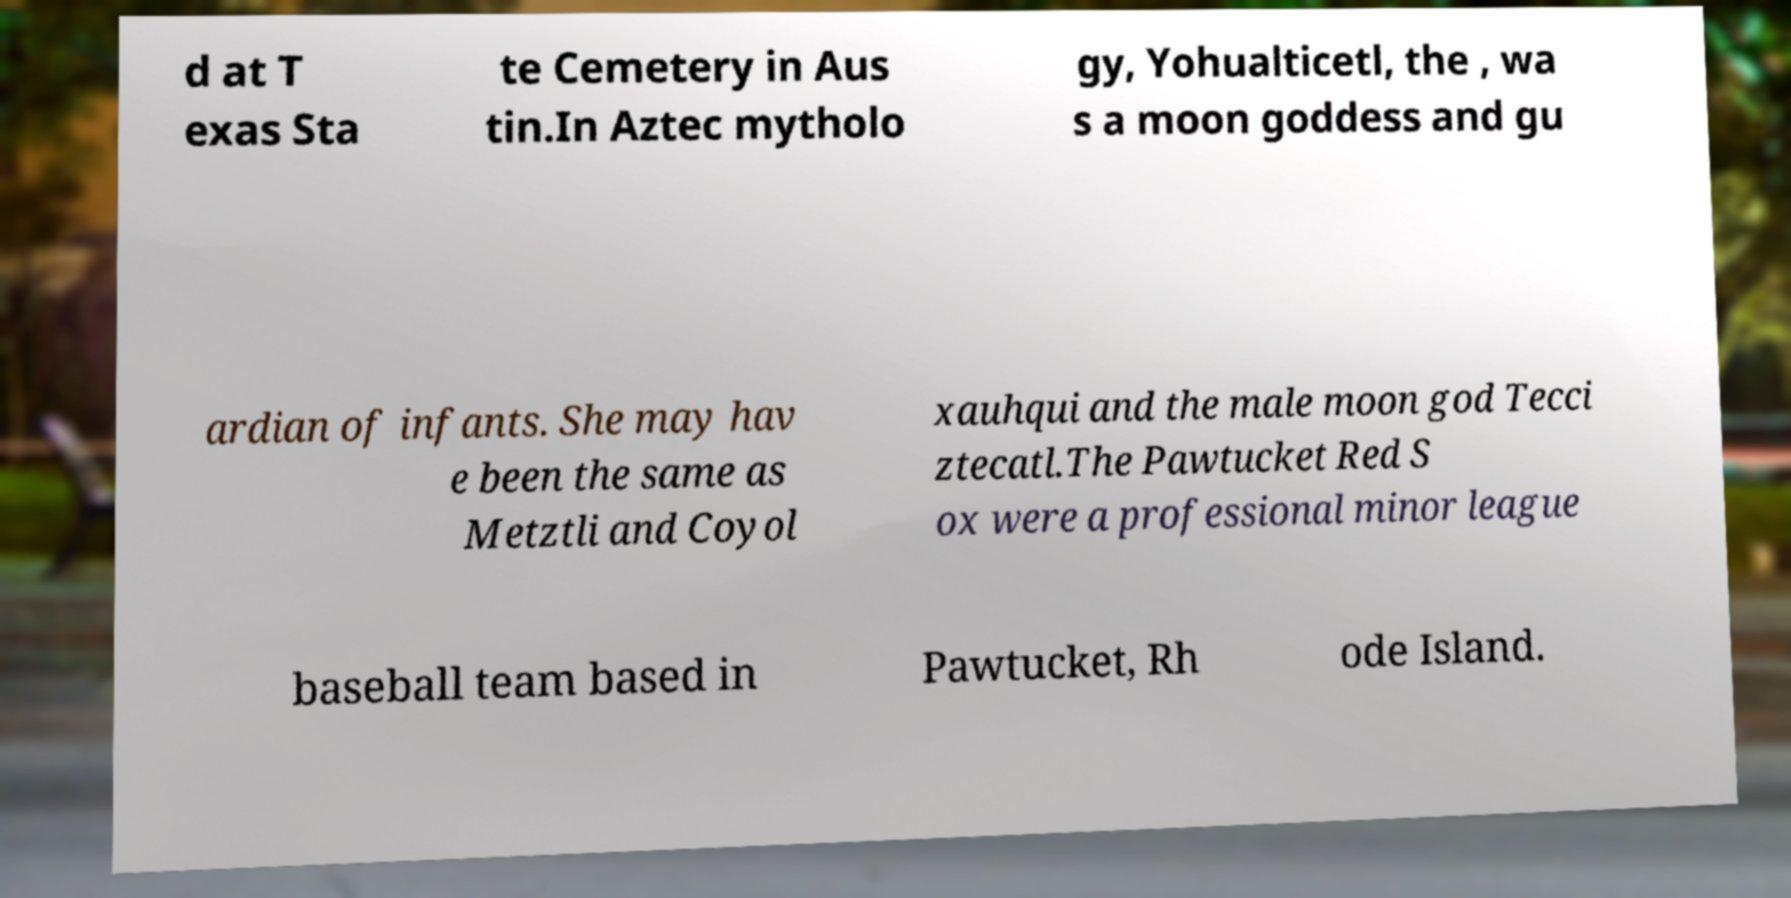Can you read and provide the text displayed in the image?This photo seems to have some interesting text. Can you extract and type it out for me? d at T exas Sta te Cemetery in Aus tin.In Aztec mytholo gy, Yohualticetl, the , wa s a moon goddess and gu ardian of infants. She may hav e been the same as Metztli and Coyol xauhqui and the male moon god Tecci ztecatl.The Pawtucket Red S ox were a professional minor league baseball team based in Pawtucket, Rh ode Island. 